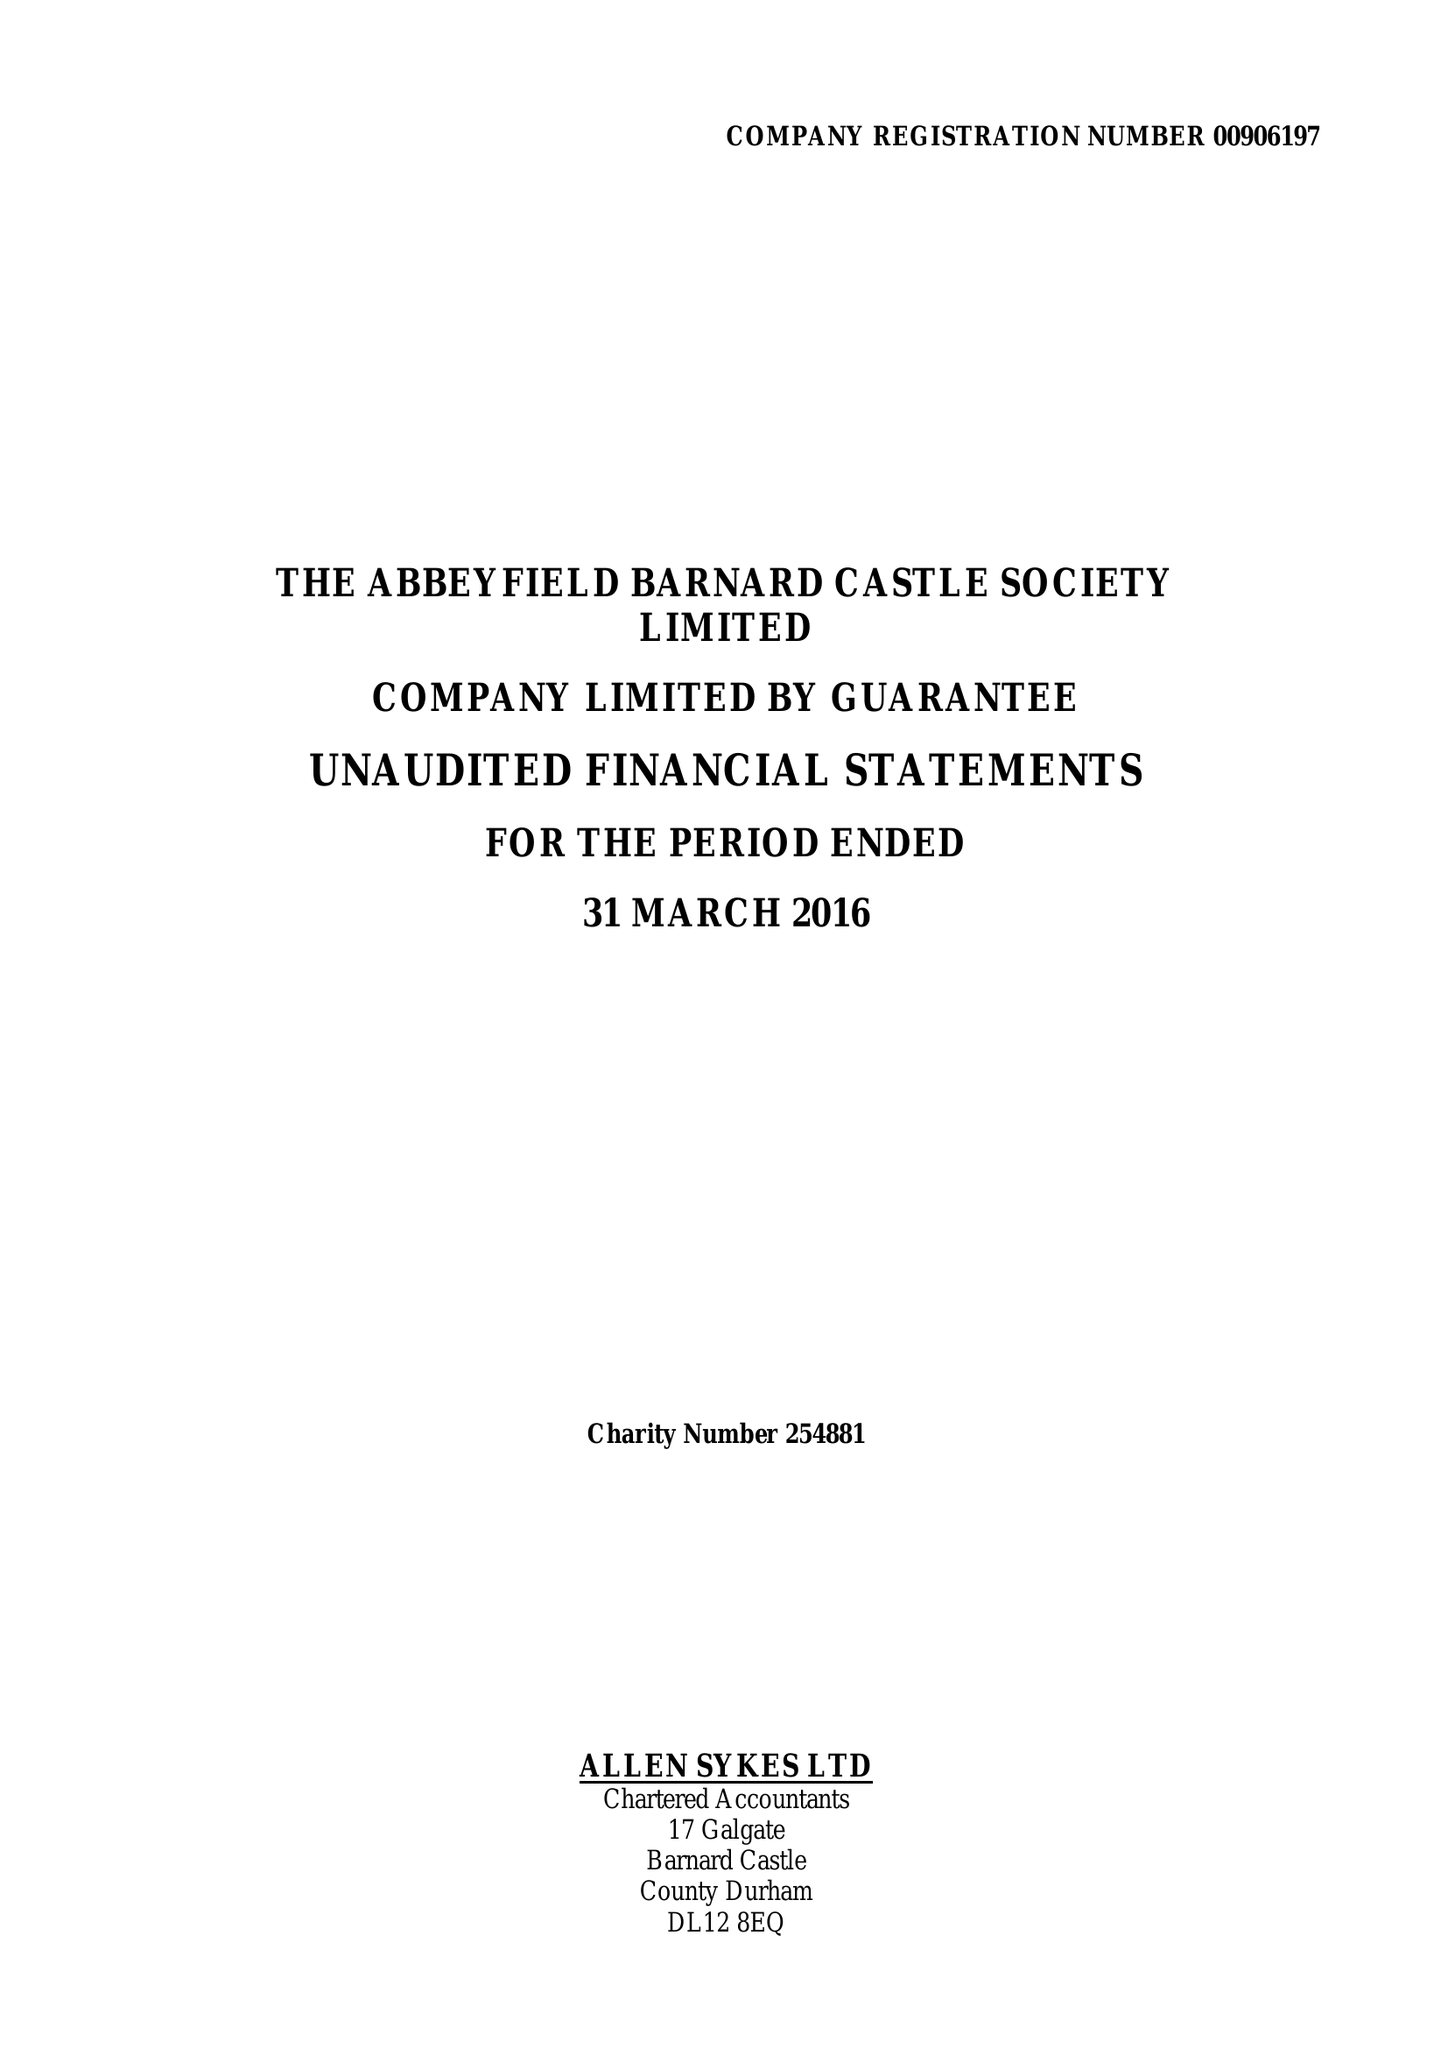What is the value for the report_date?
Answer the question using a single word or phrase. 2016-03-31 